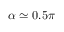<formula> <loc_0><loc_0><loc_500><loc_500>\alpha \simeq 0 . 5 \pi</formula> 